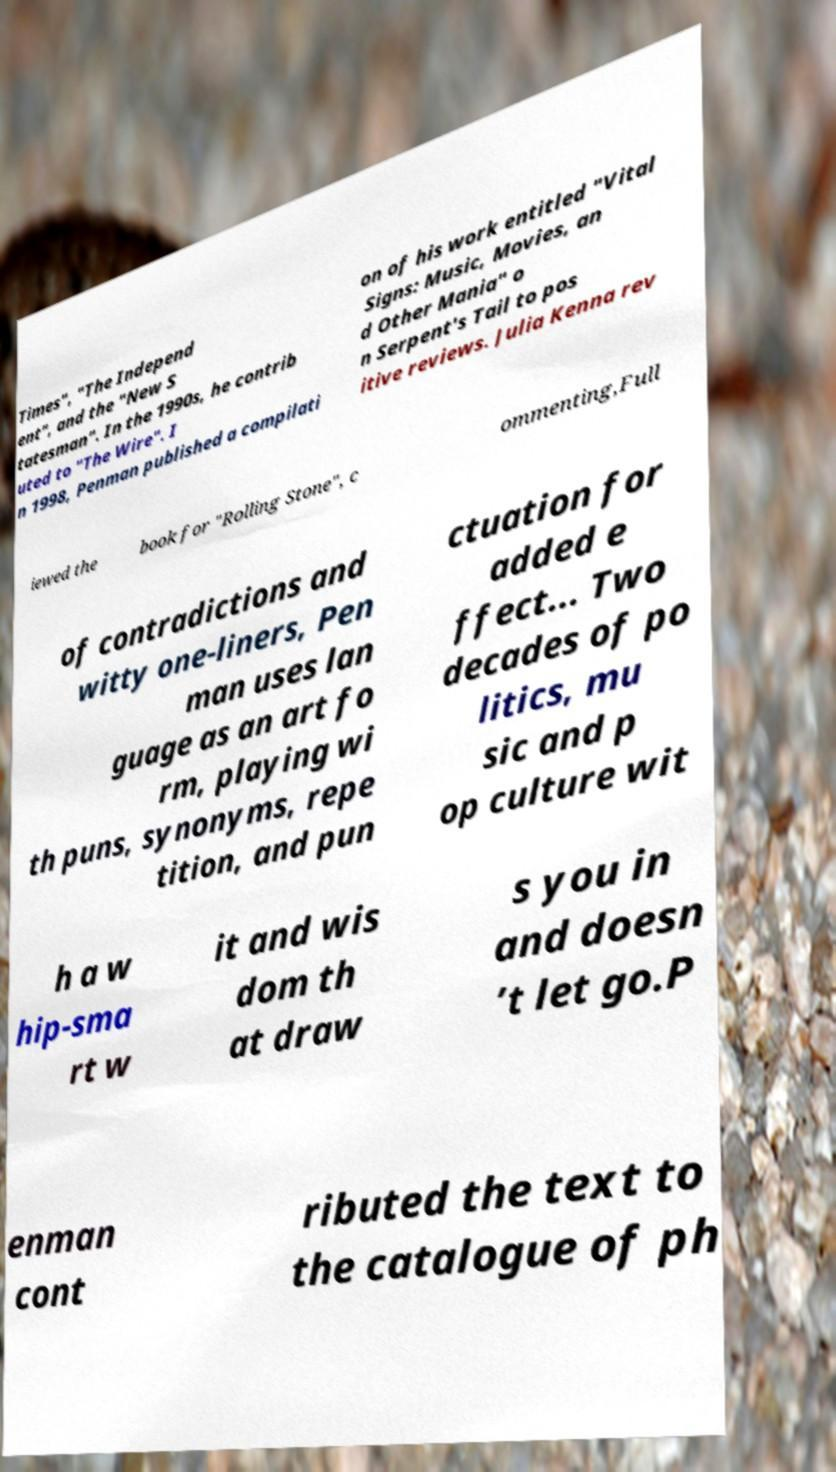Can you accurately transcribe the text from the provided image for me? Times", "The Independ ent", and the "New S tatesman". In the 1990s, he contrib uted to "The Wire". I n 1998, Penman published a compilati on of his work entitled "Vital Signs: Music, Movies, an d Other Mania" o n Serpent's Tail to pos itive reviews. Julia Kenna rev iewed the book for "Rolling Stone", c ommenting,Full of contradictions and witty one-liners, Pen man uses lan guage as an art fo rm, playing wi th puns, synonyms, repe tition, and pun ctuation for added e ffect... Two decades of po litics, mu sic and p op culture wit h a w hip-sma rt w it and wis dom th at draw s you in and doesn ’t let go.P enman cont ributed the text to the catalogue of ph 